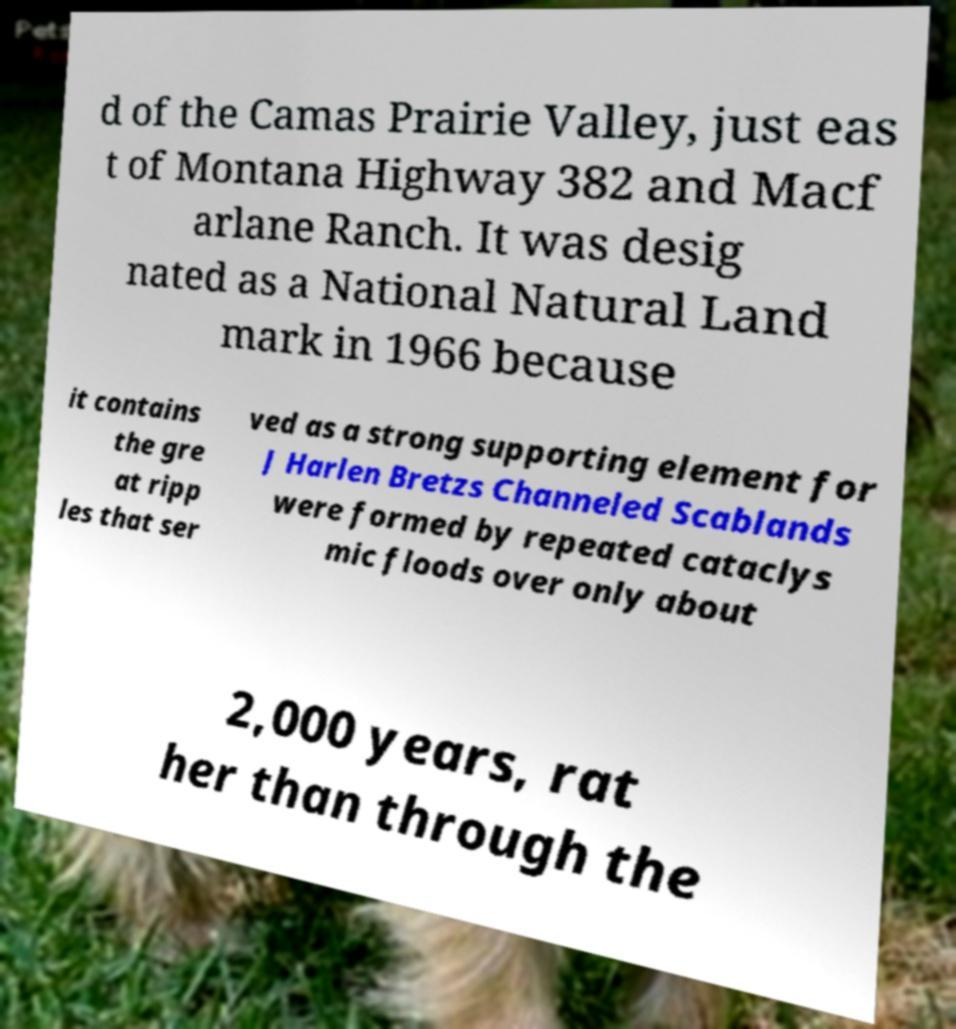Please identify and transcribe the text found in this image. d of the Camas Prairie Valley, just eas t of Montana Highway 382 and Macf arlane Ranch. It was desig nated as a National Natural Land mark in 1966 because it contains the gre at ripp les that ser ved as a strong supporting element for J Harlen Bretzs Channeled Scablands were formed by repeated cataclys mic floods over only about 2,000 years, rat her than through the 